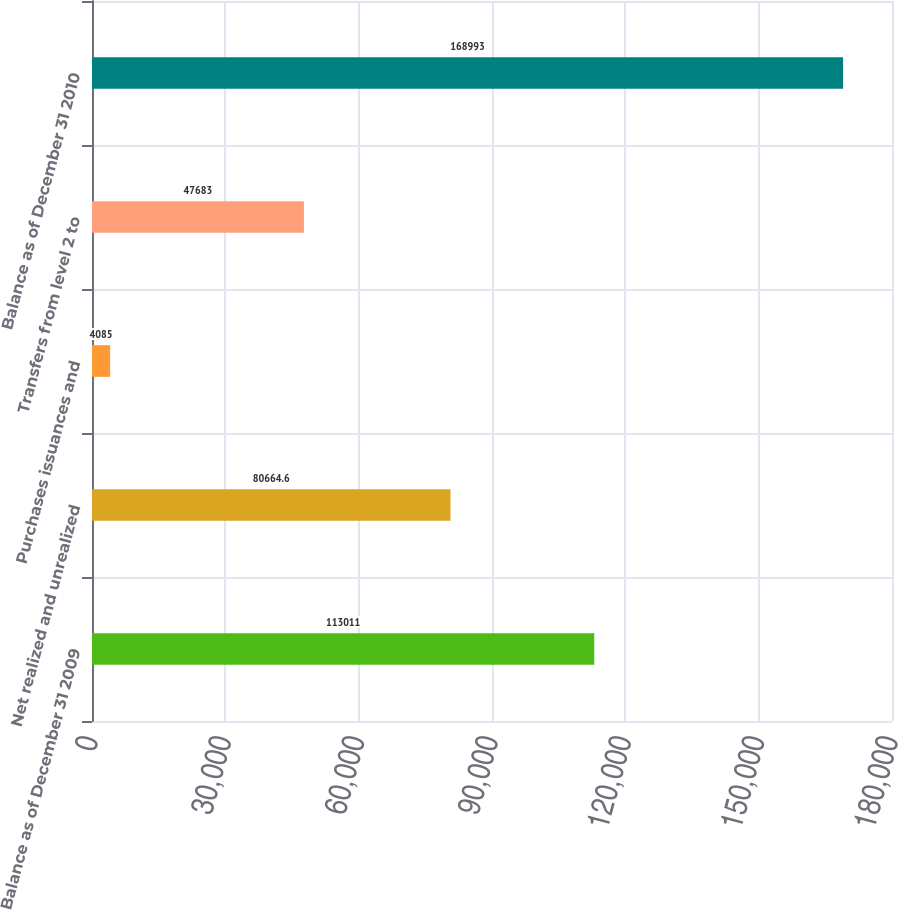Convert chart to OTSL. <chart><loc_0><loc_0><loc_500><loc_500><bar_chart><fcel>Balance as of December 31 2009<fcel>Net realized and unrealized<fcel>Purchases issuances and<fcel>Transfers from level 2 to<fcel>Balance as of December 31 2010<nl><fcel>113011<fcel>80664.6<fcel>4085<fcel>47683<fcel>168993<nl></chart> 